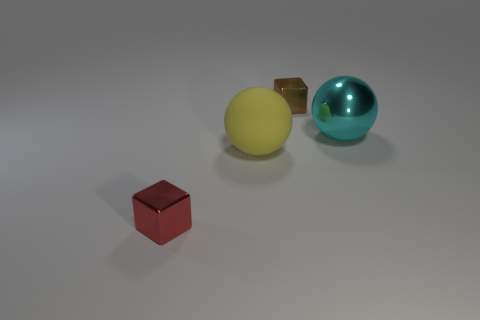How many cyan things are either tiny objects or large spheres?
Your answer should be very brief. 1. Are there the same number of cyan shiny things in front of the big yellow sphere and metal spheres?
Provide a short and direct response. No. How big is the metal cube in front of the tiny brown object?
Your response must be concise. Small. What number of other red things have the same shape as the small red object?
Your response must be concise. 0. What is the material of the object that is both to the right of the tiny red block and in front of the big cyan metallic sphere?
Make the answer very short. Rubber. Are the red object and the yellow thing made of the same material?
Offer a very short reply. No. How many small brown blocks are there?
Provide a succinct answer. 1. What is the color of the tiny shiny cube left of the tiny shiny thing that is behind the large thing in front of the cyan object?
Provide a succinct answer. Red. Do the shiny ball and the big rubber object have the same color?
Provide a short and direct response. No. What number of metallic cubes are both to the right of the red object and in front of the cyan object?
Give a very brief answer. 0. 